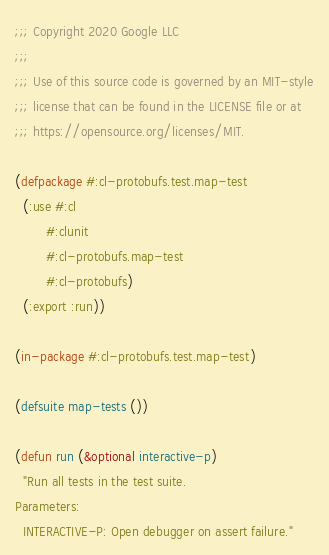Convert code to text. <code><loc_0><loc_0><loc_500><loc_500><_Lisp_>;;; Copyright 2020 Google LLC
;;;
;;; Use of this source code is governed by an MIT-style
;;; license that can be found in the LICENSE file or at
;;; https://opensource.org/licenses/MIT.

(defpackage #:cl-protobufs.test.map-test
  (:use #:cl
        #:clunit
        #:cl-protobufs.map-test
        #:cl-protobufs)
  (:export :run))

(in-package #:cl-protobufs.test.map-test)

(defsuite map-tests ())

(defun run (&optional interactive-p)
  "Run all tests in the test suite.
Parameters:
  INTERACTIVE-P: Open debugger on assert failure."</code> 